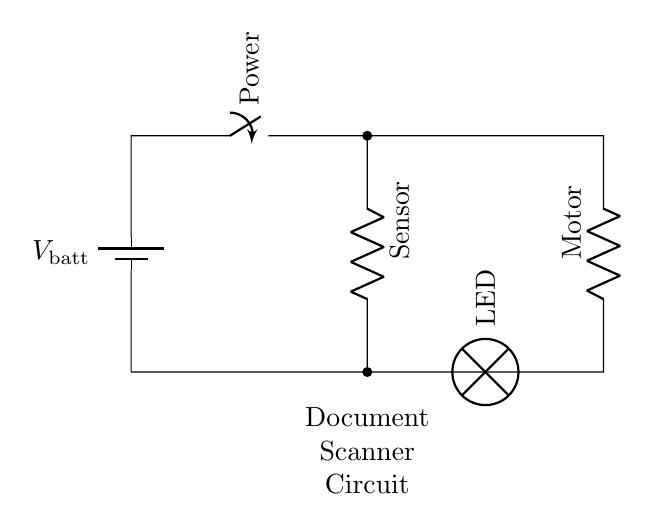What type of circuit is shown in the diagram? The circuit is a series circuit, as all components are connected in a single path for the current.
Answer: Series circuit What components are present in the circuit? The circuit contains a battery, a switch, a resistor (sensor), an LED, and a motor, all connected in series.
Answer: Battery, switch, sensor, LED, motor Which component is used to control the power in the circuit? The switch is used to open or close the circuit, thereby controlling the flow of power.
Answer: Switch What is the function of the LED in this circuit? The LED serves as an indicator that the circuit is powered and functioning, turning on when current flows through it.
Answer: Indicator What happens if the switch is open? If the switch is open, the circuit is incomplete, preventing current from flowing and all components from being inactive.
Answer: No current flows How many resistors are used in this circuit? There are two resistors in the circuit: one is labeled as the sensor, and the other is labeled as the motor.
Answer: Two 